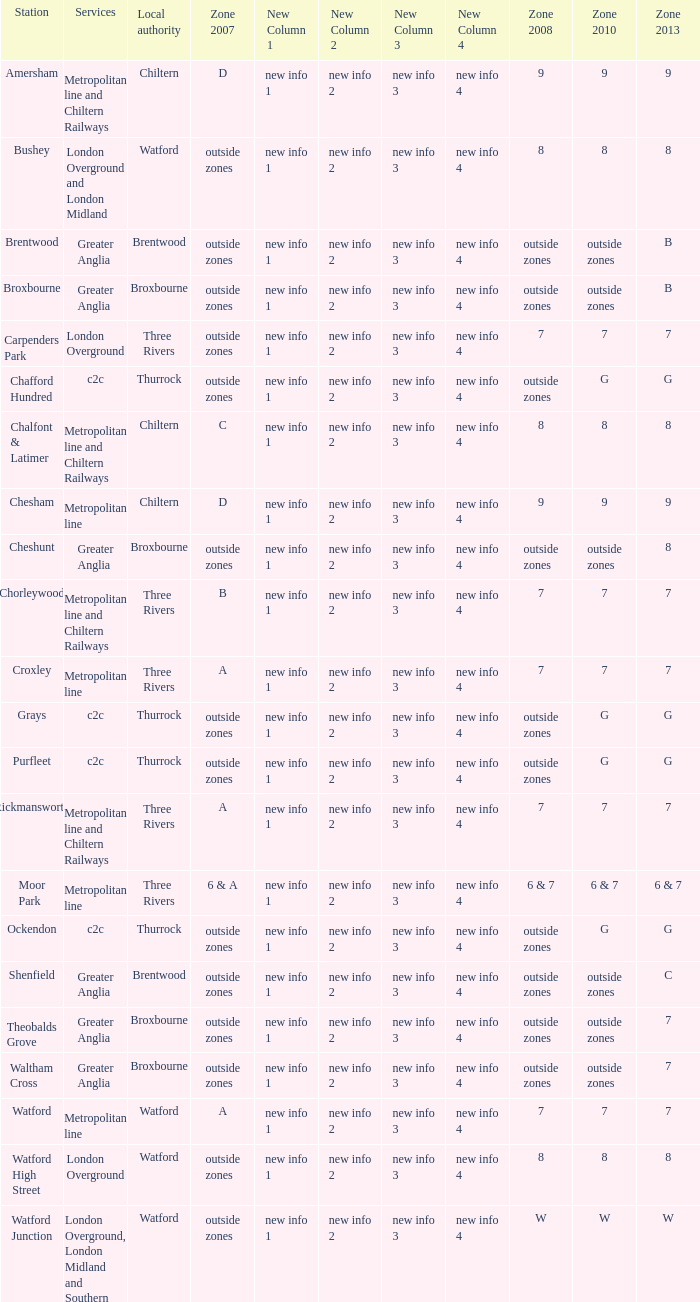Which Local authority has Services of greater anglia? Brentwood, Broxbourne, Broxbourne, Brentwood, Broxbourne, Broxbourne. 